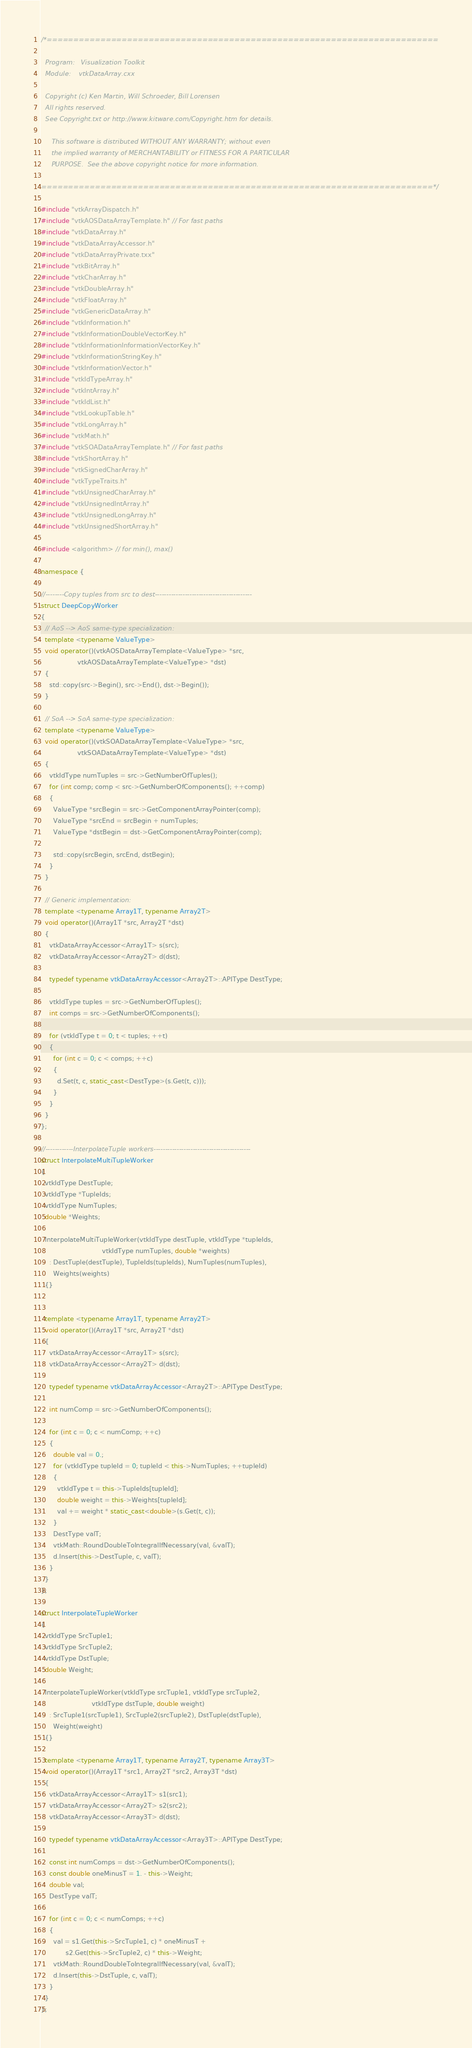Convert code to text. <code><loc_0><loc_0><loc_500><loc_500><_C++_>/*=========================================================================

  Program:   Visualization Toolkit
  Module:    vtkDataArray.cxx

  Copyright (c) Ken Martin, Will Schroeder, Bill Lorensen
  All rights reserved.
  See Copyright.txt or http://www.kitware.com/Copyright.htm for details.

     This software is distributed WITHOUT ANY WARRANTY; without even
     the implied warranty of MERCHANTABILITY or FITNESS FOR A PARTICULAR
     PURPOSE.  See the above copyright notice for more information.

=========================================================================*/

#include "vtkArrayDispatch.h"
#include "vtkAOSDataArrayTemplate.h" // For fast paths
#include "vtkDataArray.h"
#include "vtkDataArrayAccessor.h"
#include "vtkDataArrayPrivate.txx"
#include "vtkBitArray.h"
#include "vtkCharArray.h"
#include "vtkDoubleArray.h"
#include "vtkFloatArray.h"
#include "vtkGenericDataArray.h"
#include "vtkInformation.h"
#include "vtkInformationDoubleVectorKey.h"
#include "vtkInformationInformationVectorKey.h"
#include "vtkInformationStringKey.h"
#include "vtkInformationVector.h"
#include "vtkIdTypeArray.h"
#include "vtkIntArray.h"
#include "vtkIdList.h"
#include "vtkLookupTable.h"
#include "vtkLongArray.h"
#include "vtkMath.h"
#include "vtkSOADataArrayTemplate.h" // For fast paths
#include "vtkShortArray.h"
#include "vtkSignedCharArray.h"
#include "vtkTypeTraits.h"
#include "vtkUnsignedCharArray.h"
#include "vtkUnsignedIntArray.h"
#include "vtkUnsignedLongArray.h"
#include "vtkUnsignedShortArray.h"

#include <algorithm> // for min(), max()

namespace {

//--------Copy tuples from src to dest------------------------------------------
struct DeepCopyWorker
{
  // AoS --> AoS same-type specialization:
  template <typename ValueType>
  void operator()(vtkAOSDataArrayTemplate<ValueType> *src,
                  vtkAOSDataArrayTemplate<ValueType> *dst)
  {
    std::copy(src->Begin(), src->End(), dst->Begin());
  }

  // SoA --> SoA same-type specialization:
  template <typename ValueType>
  void operator()(vtkSOADataArrayTemplate<ValueType> *src,
                  vtkSOADataArrayTemplate<ValueType> *dst)
  {
    vtkIdType numTuples = src->GetNumberOfTuples();
    for (int comp; comp < src->GetNumberOfComponents(); ++comp)
    {
      ValueType *srcBegin = src->GetComponentArrayPointer(comp);
      ValueType *srcEnd = srcBegin + numTuples;
      ValueType *dstBegin = dst->GetComponentArrayPointer(comp);

      std::copy(srcBegin, srcEnd, dstBegin);
    }
  }

  // Generic implementation:
  template <typename Array1T, typename Array2T>
  void operator()(Array1T *src, Array2T *dst)
  {
    vtkDataArrayAccessor<Array1T> s(src);
    vtkDataArrayAccessor<Array2T> d(dst);

    typedef typename vtkDataArrayAccessor<Array2T>::APIType DestType;

    vtkIdType tuples = src->GetNumberOfTuples();
    int comps = src->GetNumberOfComponents();

    for (vtkIdType t = 0; t < tuples; ++t)
    {
      for (int c = 0; c < comps; ++c)
      {
        d.Set(t, c, static_cast<DestType>(s.Get(t, c)));
      }
    }
  }
};

//------------InterpolateTuple workers------------------------------------------
struct InterpolateMultiTupleWorker
{
  vtkIdType DestTuple;
  vtkIdType *TupleIds;
  vtkIdType NumTuples;
  double *Weights;

  InterpolateMultiTupleWorker(vtkIdType destTuple, vtkIdType *tupleIds,
                              vtkIdType numTuples, double *weights)
    : DestTuple(destTuple), TupleIds(tupleIds), NumTuples(numTuples),
      Weights(weights)
  {}


  template <typename Array1T, typename Array2T>
  void operator()(Array1T *src, Array2T *dst)
  {
    vtkDataArrayAccessor<Array1T> s(src);
    vtkDataArrayAccessor<Array2T> d(dst);

    typedef typename vtkDataArrayAccessor<Array2T>::APIType DestType;

    int numComp = src->GetNumberOfComponents();

    for (int c = 0; c < numComp; ++c)
    {
      double val = 0.;
      for (vtkIdType tupleId = 0; tupleId < this->NumTuples; ++tupleId)
      {
        vtkIdType t = this->TupleIds[tupleId];
        double weight = this->Weights[tupleId];
        val += weight * static_cast<double>(s.Get(t, c));
      }
      DestType valT;
      vtkMath::RoundDoubleToIntegralIfNecessary(val, &valT);
      d.Insert(this->DestTuple, c, valT);
    }
  }
};

struct InterpolateTupleWorker
{
  vtkIdType SrcTuple1;
  vtkIdType SrcTuple2;
  vtkIdType DstTuple;
  double Weight;

  InterpolateTupleWorker(vtkIdType srcTuple1, vtkIdType srcTuple2,
                         vtkIdType dstTuple, double weight)
    : SrcTuple1(srcTuple1), SrcTuple2(srcTuple2), DstTuple(dstTuple),
      Weight(weight)
  {}

  template <typename Array1T, typename Array2T, typename Array3T>
  void operator()(Array1T *src1, Array2T *src2, Array3T *dst)
  {
    vtkDataArrayAccessor<Array1T> s1(src1);
    vtkDataArrayAccessor<Array2T> s2(src2);
    vtkDataArrayAccessor<Array3T> d(dst);

    typedef typename vtkDataArrayAccessor<Array3T>::APIType DestType;

    const int numComps = dst->GetNumberOfComponents();
    const double oneMinusT = 1. - this->Weight;
    double val;
    DestType valT;

    for (int c = 0; c < numComps; ++c)
    {
      val = s1.Get(this->SrcTuple1, c) * oneMinusT +
            s2.Get(this->SrcTuple2, c) * this->Weight;
      vtkMath::RoundDoubleToIntegralIfNecessary(val, &valT);
      d.Insert(this->DstTuple, c, valT);
    }
  }
};
</code> 